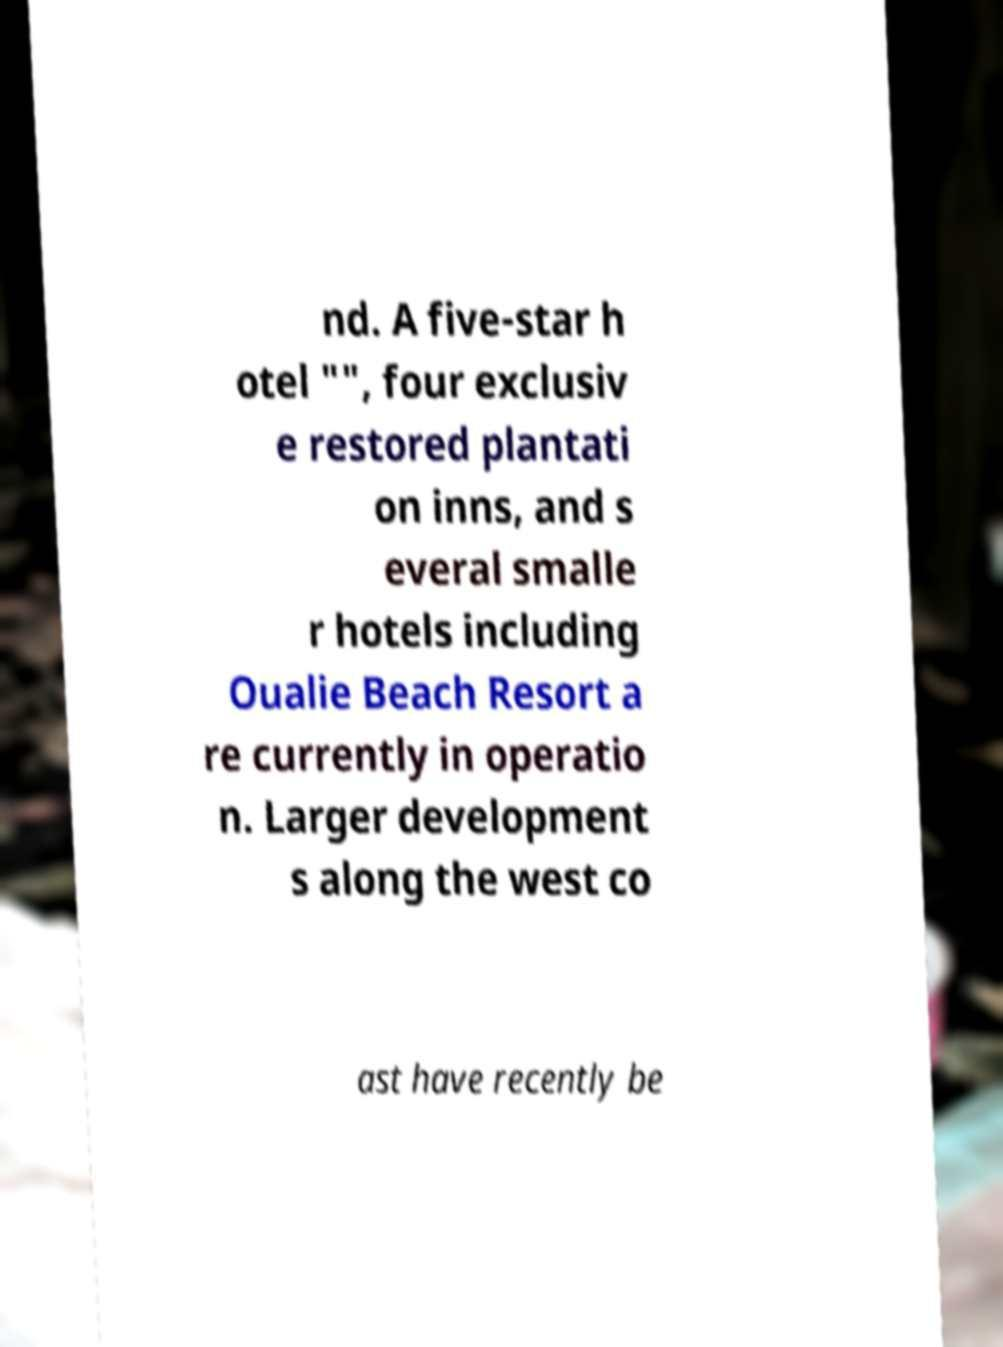Could you assist in decoding the text presented in this image and type it out clearly? nd. A five-star h otel "", four exclusiv e restored plantati on inns, and s everal smalle r hotels including Oualie Beach Resort a re currently in operatio n. Larger development s along the west co ast have recently be 